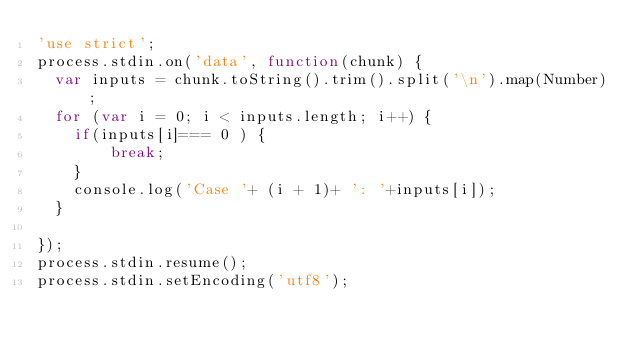Convert code to text. <code><loc_0><loc_0><loc_500><loc_500><_JavaScript_>'use strict';
process.stdin.on('data', function(chunk) {
  var inputs = chunk.toString().trim().split('\n').map(Number);
  for (var i = 0; i < inputs.length; i++) {
    if(inputs[i]=== 0 ) {
        break;
    }
    console.log('Case '+ (i + 1)+ ': '+inputs[i]);
  }
   
});
process.stdin.resume();
process.stdin.setEncoding('utf8');</code> 